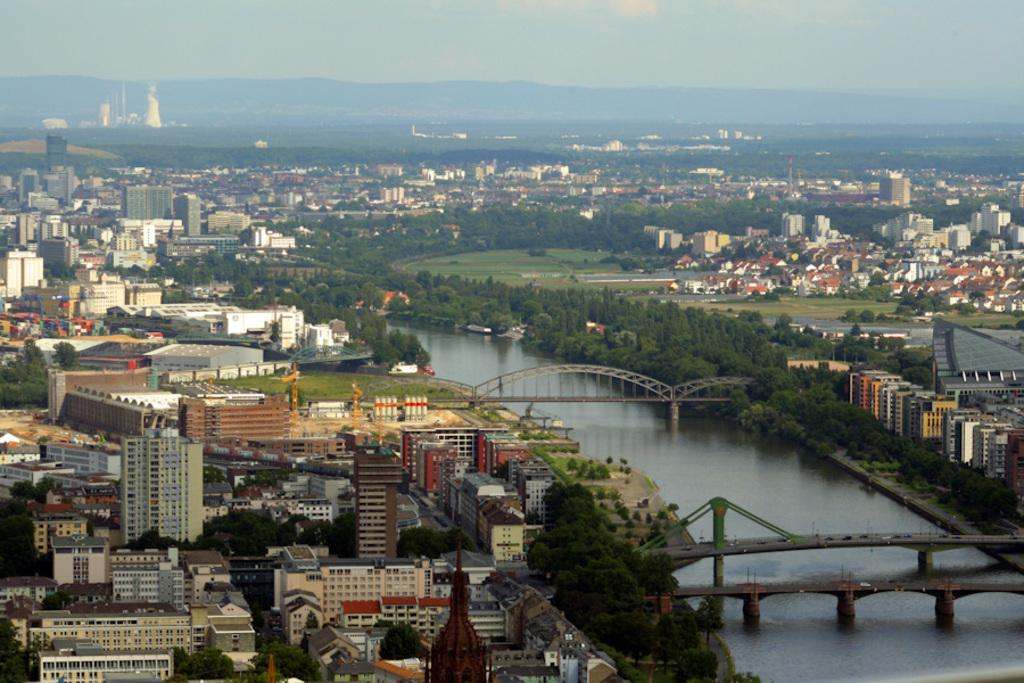What type of structures can be seen in the image? There are buildings with windows in the image. What other natural elements are present in the image? There are trees and water visible in the image. Are there any man-made structures besides buildings? Yes, there are bridges in the image. What can be seen in the background of the image? There are mountains and the sky visible in the background of the image. What is the condition of the sky in the image? The sky has clouds present in it. What type of game is being played on the crook in the image? There is no crook or game present in the image. What type of treatment is being administered to the trees in the image? There is no treatment being administered to the trees in the image; they appear to be natural and healthy. 